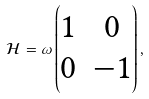<formula> <loc_0><loc_0><loc_500><loc_500>\mathcal { H } = \omega \begin{pmatrix} 1 & 0 \\ 0 & - 1 \end{pmatrix} ,</formula> 